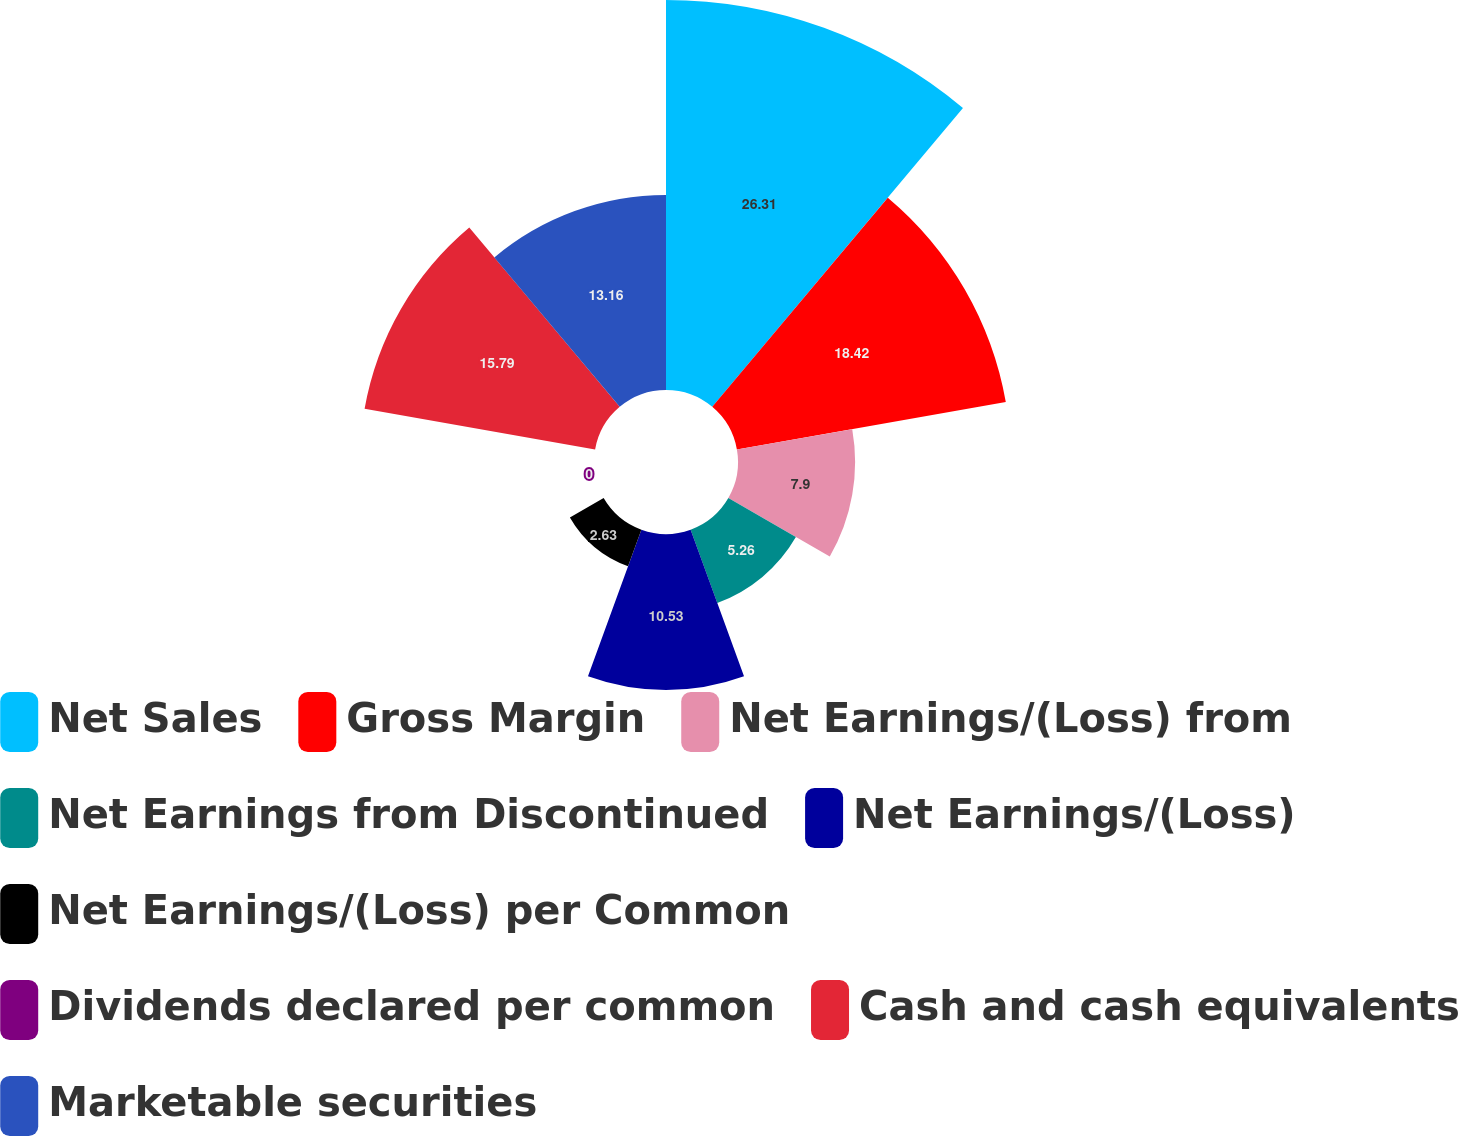Convert chart to OTSL. <chart><loc_0><loc_0><loc_500><loc_500><pie_chart><fcel>Net Sales<fcel>Gross Margin<fcel>Net Earnings/(Loss) from<fcel>Net Earnings from Discontinued<fcel>Net Earnings/(Loss)<fcel>Net Earnings/(Loss) per Common<fcel>Dividends declared per common<fcel>Cash and cash equivalents<fcel>Marketable securities<nl><fcel>26.31%<fcel>18.42%<fcel>7.9%<fcel>5.26%<fcel>10.53%<fcel>2.63%<fcel>0.0%<fcel>15.79%<fcel>13.16%<nl></chart> 